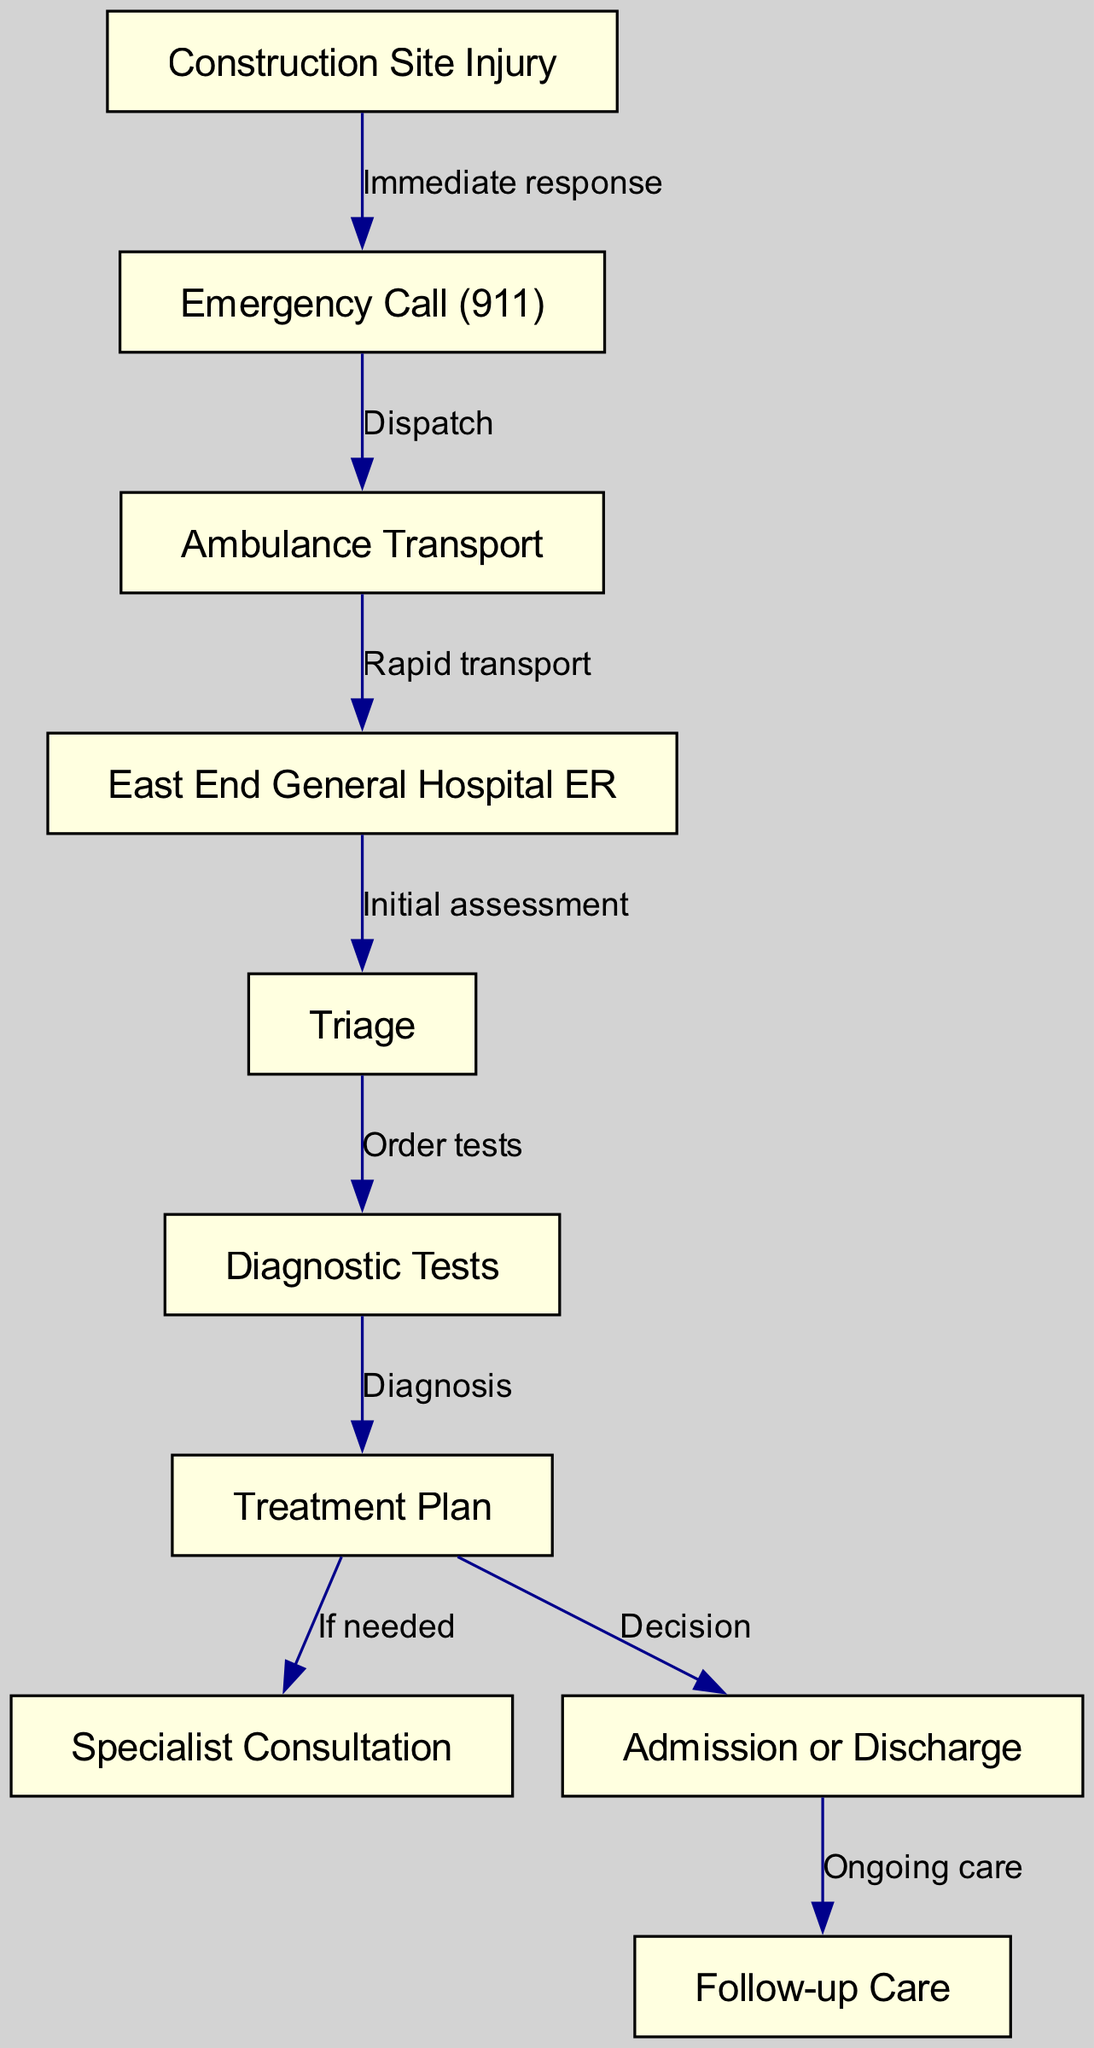What is the first step after a construction site injury occurs? The diagram shows an arrow from the "Construction Site Injury" node leading to the "Emergency Call (911)" node. Therefore, the first step is to make an emergency call.
Answer: Emergency Call (911) How many nodes are in the diagram? The diagram contains a total of 10 nodes, as listed under the "nodes" section in the data.
Answer: 10 What follows after triage in the pathway? Triage leads to "Diagnostic Tests" as indicated by the arrow from the "Triage" node to the "Diagnostic Tests" node.
Answer: Diagnostic Tests What is the result of the treatment plan? The treatment plan can lead to either "Specialist Consultation" or "Admission or Discharge" as indicated by the arrows branching from the "Treatment Plan" node. Thus, the result could be either option.
Answer: Specialist Consultation or Admission or Discharge What is the relationship between ambulance transport and the hospital? The diagram shows that the "Ambulance Transport" node connects to "East End General Hospital ER," indicating that the transport is conducted to this specific hospital.
Answer: East End General Hospital ER How does follow-up care relate to admission or discharge? The arrow from "Admission or Discharge" to "Follow-up Care" indicates that follow-up care occurs after a decision is made about admission or discharge, showing a direct relationship between these two steps.
Answer: Follow-up Care Which node represents the initial assessment? The node labeled "Triage" represents the initial assessment as depicted in the diagram.
Answer: Triage What action is taken after diagnostic tests? After "Diagnostic Tests," the next action is to form a "Treatment Plan." This is indicated by the arrow from "Diagnostic Tests" to "Treatment Plan."
Answer: Treatment Plan What is the role of emergency call in the clinical pathway? The emergency call initiates the process and is essential for dispatching the ambulance, highlighted by the direct link from the "Emergency Call (911)" node to "Ambulance Transport."
Answer: Dispatch 